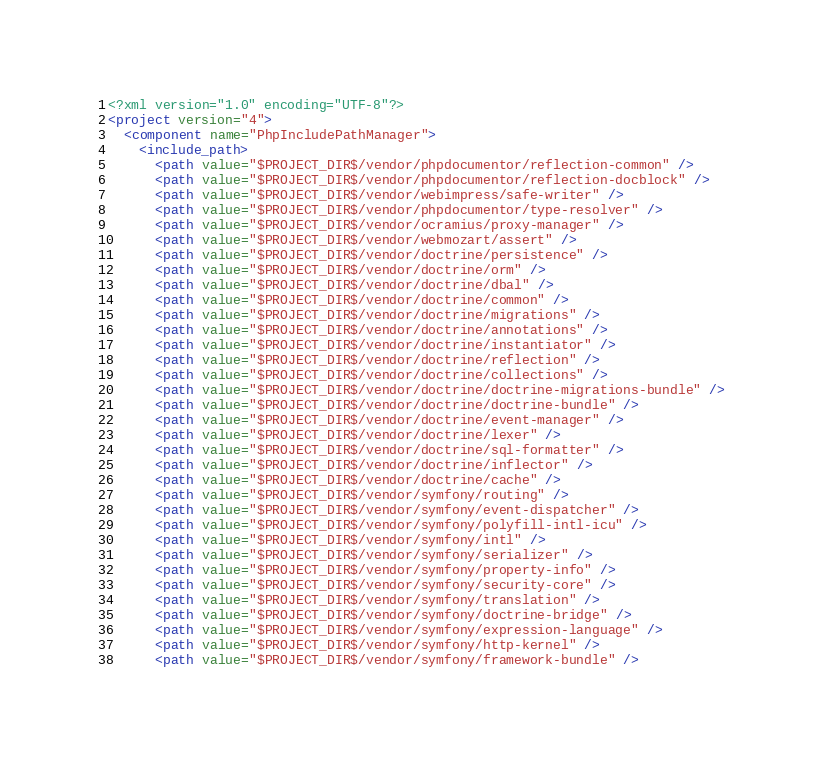<code> <loc_0><loc_0><loc_500><loc_500><_XML_><?xml version="1.0" encoding="UTF-8"?>
<project version="4">
  <component name="PhpIncludePathManager">
    <include_path>
      <path value="$PROJECT_DIR$/vendor/phpdocumentor/reflection-common" />
      <path value="$PROJECT_DIR$/vendor/phpdocumentor/reflection-docblock" />
      <path value="$PROJECT_DIR$/vendor/webimpress/safe-writer" />
      <path value="$PROJECT_DIR$/vendor/phpdocumentor/type-resolver" />
      <path value="$PROJECT_DIR$/vendor/ocramius/proxy-manager" />
      <path value="$PROJECT_DIR$/vendor/webmozart/assert" />
      <path value="$PROJECT_DIR$/vendor/doctrine/persistence" />
      <path value="$PROJECT_DIR$/vendor/doctrine/orm" />
      <path value="$PROJECT_DIR$/vendor/doctrine/dbal" />
      <path value="$PROJECT_DIR$/vendor/doctrine/common" />
      <path value="$PROJECT_DIR$/vendor/doctrine/migrations" />
      <path value="$PROJECT_DIR$/vendor/doctrine/annotations" />
      <path value="$PROJECT_DIR$/vendor/doctrine/instantiator" />
      <path value="$PROJECT_DIR$/vendor/doctrine/reflection" />
      <path value="$PROJECT_DIR$/vendor/doctrine/collections" />
      <path value="$PROJECT_DIR$/vendor/doctrine/doctrine-migrations-bundle" />
      <path value="$PROJECT_DIR$/vendor/doctrine/doctrine-bundle" />
      <path value="$PROJECT_DIR$/vendor/doctrine/event-manager" />
      <path value="$PROJECT_DIR$/vendor/doctrine/lexer" />
      <path value="$PROJECT_DIR$/vendor/doctrine/sql-formatter" />
      <path value="$PROJECT_DIR$/vendor/doctrine/inflector" />
      <path value="$PROJECT_DIR$/vendor/doctrine/cache" />
      <path value="$PROJECT_DIR$/vendor/symfony/routing" />
      <path value="$PROJECT_DIR$/vendor/symfony/event-dispatcher" />
      <path value="$PROJECT_DIR$/vendor/symfony/polyfill-intl-icu" />
      <path value="$PROJECT_DIR$/vendor/symfony/intl" />
      <path value="$PROJECT_DIR$/vendor/symfony/serializer" />
      <path value="$PROJECT_DIR$/vendor/symfony/property-info" />
      <path value="$PROJECT_DIR$/vendor/symfony/security-core" />
      <path value="$PROJECT_DIR$/vendor/symfony/translation" />
      <path value="$PROJECT_DIR$/vendor/symfony/doctrine-bridge" />
      <path value="$PROJECT_DIR$/vendor/symfony/expression-language" />
      <path value="$PROJECT_DIR$/vendor/symfony/http-kernel" />
      <path value="$PROJECT_DIR$/vendor/symfony/framework-bundle" /></code> 